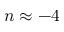<formula> <loc_0><loc_0><loc_500><loc_500>n \approx - 4</formula> 